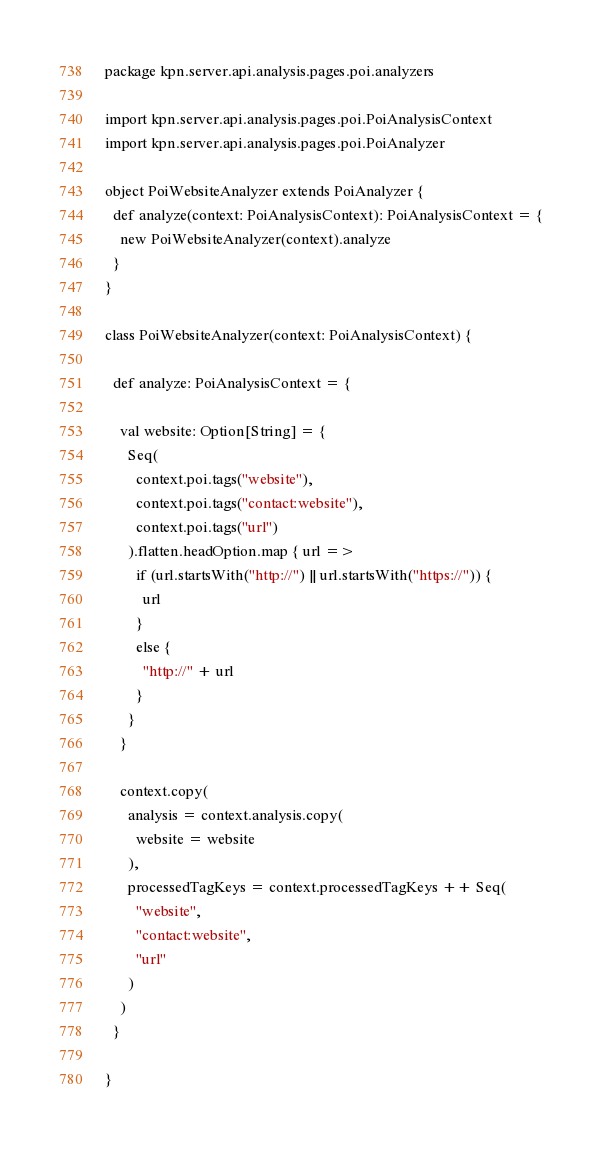<code> <loc_0><loc_0><loc_500><loc_500><_Scala_>package kpn.server.api.analysis.pages.poi.analyzers

import kpn.server.api.analysis.pages.poi.PoiAnalysisContext
import kpn.server.api.analysis.pages.poi.PoiAnalyzer

object PoiWebsiteAnalyzer extends PoiAnalyzer {
  def analyze(context: PoiAnalysisContext): PoiAnalysisContext = {
    new PoiWebsiteAnalyzer(context).analyze
  }
}

class PoiWebsiteAnalyzer(context: PoiAnalysisContext) {

  def analyze: PoiAnalysisContext = {

    val website: Option[String] = {
      Seq(
        context.poi.tags("website"),
        context.poi.tags("contact:website"),
        context.poi.tags("url")
      ).flatten.headOption.map { url =>
        if (url.startsWith("http://") || url.startsWith("https://")) {
          url
        }
        else {
          "http://" + url
        }
      }
    }

    context.copy(
      analysis = context.analysis.copy(
        website = website
      ),
      processedTagKeys = context.processedTagKeys ++ Seq(
        "website",
        "contact:website",
        "url"
      )
    )
  }

}
</code> 